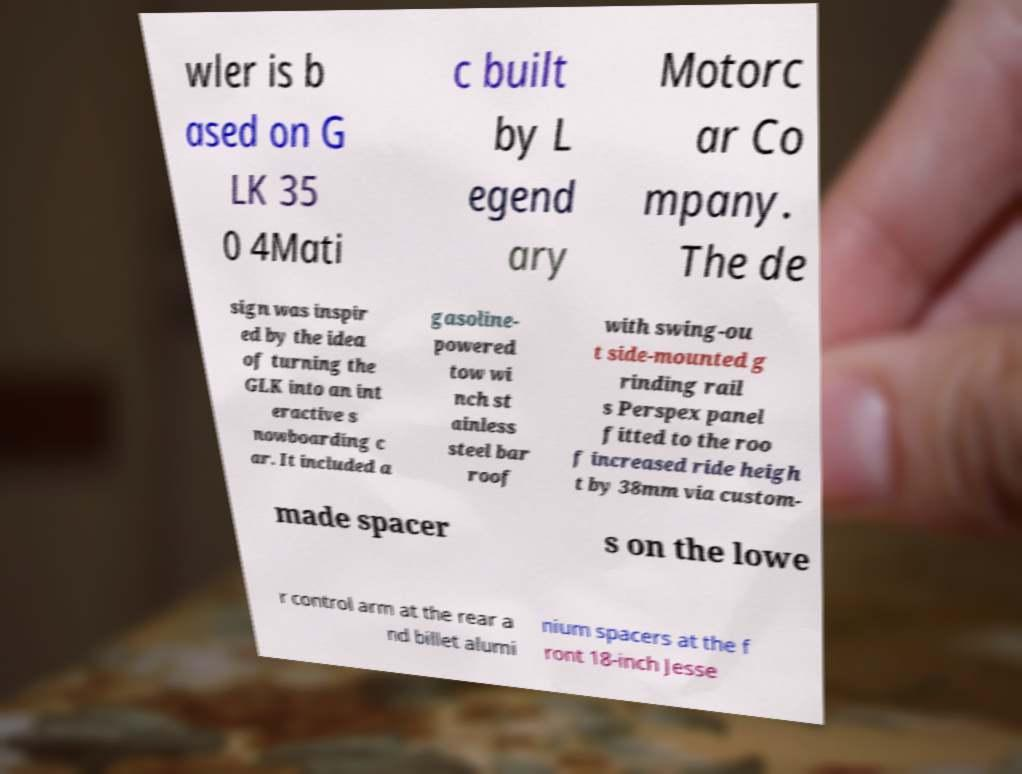Please read and relay the text visible in this image. What does it say? wler is b ased on G LK 35 0 4Mati c built by L egend ary Motorc ar Co mpany. The de sign was inspir ed by the idea of turning the GLK into an int eractive s nowboarding c ar. It included a gasoline- powered tow wi nch st ainless steel bar roof with swing-ou t side-mounted g rinding rail s Perspex panel fitted to the roo f increased ride heigh t by 38mm via custom- made spacer s on the lowe r control arm at the rear a nd billet alumi nium spacers at the f ront 18-inch Jesse 